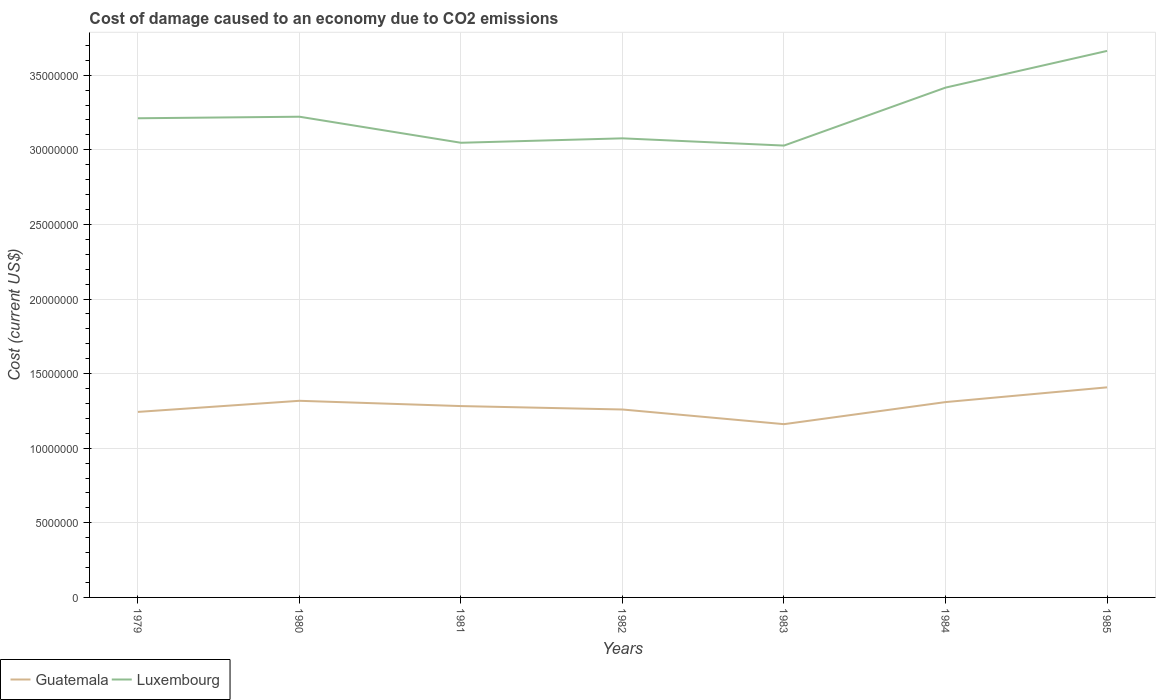Across all years, what is the maximum cost of damage caused due to CO2 emissisons in Luxembourg?
Make the answer very short. 3.03e+07. In which year was the cost of damage caused due to CO2 emissisons in Luxembourg maximum?
Keep it short and to the point. 1983. What is the total cost of damage caused due to CO2 emissisons in Luxembourg in the graph?
Your answer should be compact. -3.88e+06. What is the difference between the highest and the second highest cost of damage caused due to CO2 emissisons in Guatemala?
Make the answer very short. 2.47e+06. What is the difference between the highest and the lowest cost of damage caused due to CO2 emissisons in Luxembourg?
Your response must be concise. 2. How many lines are there?
Offer a very short reply. 2. What is the difference between two consecutive major ticks on the Y-axis?
Keep it short and to the point. 5.00e+06. Are the values on the major ticks of Y-axis written in scientific E-notation?
Your response must be concise. No. Does the graph contain grids?
Give a very brief answer. Yes. How many legend labels are there?
Your answer should be very brief. 2. What is the title of the graph?
Make the answer very short. Cost of damage caused to an economy due to CO2 emissions. Does "Burundi" appear as one of the legend labels in the graph?
Make the answer very short. No. What is the label or title of the X-axis?
Your answer should be compact. Years. What is the label or title of the Y-axis?
Your response must be concise. Cost (current US$). What is the Cost (current US$) of Guatemala in 1979?
Keep it short and to the point. 1.24e+07. What is the Cost (current US$) in Luxembourg in 1979?
Make the answer very short. 3.21e+07. What is the Cost (current US$) of Guatemala in 1980?
Your response must be concise. 1.32e+07. What is the Cost (current US$) in Luxembourg in 1980?
Provide a short and direct response. 3.22e+07. What is the Cost (current US$) in Guatemala in 1981?
Offer a terse response. 1.28e+07. What is the Cost (current US$) in Luxembourg in 1981?
Give a very brief answer. 3.05e+07. What is the Cost (current US$) in Guatemala in 1982?
Give a very brief answer. 1.26e+07. What is the Cost (current US$) in Luxembourg in 1982?
Offer a terse response. 3.08e+07. What is the Cost (current US$) of Guatemala in 1983?
Make the answer very short. 1.16e+07. What is the Cost (current US$) in Luxembourg in 1983?
Your answer should be compact. 3.03e+07. What is the Cost (current US$) in Guatemala in 1984?
Ensure brevity in your answer.  1.31e+07. What is the Cost (current US$) in Luxembourg in 1984?
Make the answer very short. 3.42e+07. What is the Cost (current US$) in Guatemala in 1985?
Your answer should be very brief. 1.41e+07. What is the Cost (current US$) in Luxembourg in 1985?
Your response must be concise. 3.66e+07. Across all years, what is the maximum Cost (current US$) in Guatemala?
Provide a succinct answer. 1.41e+07. Across all years, what is the maximum Cost (current US$) of Luxembourg?
Offer a very short reply. 3.66e+07. Across all years, what is the minimum Cost (current US$) in Guatemala?
Your response must be concise. 1.16e+07. Across all years, what is the minimum Cost (current US$) in Luxembourg?
Give a very brief answer. 3.03e+07. What is the total Cost (current US$) in Guatemala in the graph?
Your answer should be compact. 8.98e+07. What is the total Cost (current US$) of Luxembourg in the graph?
Offer a very short reply. 2.27e+08. What is the difference between the Cost (current US$) of Guatemala in 1979 and that in 1980?
Keep it short and to the point. -7.45e+05. What is the difference between the Cost (current US$) in Luxembourg in 1979 and that in 1980?
Provide a short and direct response. -1.04e+05. What is the difference between the Cost (current US$) in Guatemala in 1979 and that in 1981?
Ensure brevity in your answer.  -3.90e+05. What is the difference between the Cost (current US$) in Luxembourg in 1979 and that in 1981?
Your answer should be very brief. 1.64e+06. What is the difference between the Cost (current US$) in Guatemala in 1979 and that in 1982?
Keep it short and to the point. -1.62e+05. What is the difference between the Cost (current US$) in Luxembourg in 1979 and that in 1982?
Make the answer very short. 1.35e+06. What is the difference between the Cost (current US$) of Guatemala in 1979 and that in 1983?
Provide a short and direct response. 8.21e+05. What is the difference between the Cost (current US$) in Luxembourg in 1979 and that in 1983?
Your answer should be very brief. 1.83e+06. What is the difference between the Cost (current US$) of Guatemala in 1979 and that in 1984?
Provide a short and direct response. -6.58e+05. What is the difference between the Cost (current US$) of Luxembourg in 1979 and that in 1984?
Give a very brief answer. -2.05e+06. What is the difference between the Cost (current US$) in Guatemala in 1979 and that in 1985?
Ensure brevity in your answer.  -1.65e+06. What is the difference between the Cost (current US$) in Luxembourg in 1979 and that in 1985?
Ensure brevity in your answer.  -4.51e+06. What is the difference between the Cost (current US$) of Guatemala in 1980 and that in 1981?
Make the answer very short. 3.55e+05. What is the difference between the Cost (current US$) in Luxembourg in 1980 and that in 1981?
Offer a terse response. 1.75e+06. What is the difference between the Cost (current US$) of Guatemala in 1980 and that in 1982?
Give a very brief answer. 5.83e+05. What is the difference between the Cost (current US$) of Luxembourg in 1980 and that in 1982?
Your response must be concise. 1.45e+06. What is the difference between the Cost (current US$) in Guatemala in 1980 and that in 1983?
Keep it short and to the point. 1.57e+06. What is the difference between the Cost (current US$) in Luxembourg in 1980 and that in 1983?
Your answer should be very brief. 1.93e+06. What is the difference between the Cost (current US$) of Guatemala in 1980 and that in 1984?
Your answer should be very brief. 8.67e+04. What is the difference between the Cost (current US$) of Luxembourg in 1980 and that in 1984?
Give a very brief answer. -1.95e+06. What is the difference between the Cost (current US$) in Guatemala in 1980 and that in 1985?
Keep it short and to the point. -9.01e+05. What is the difference between the Cost (current US$) of Luxembourg in 1980 and that in 1985?
Your answer should be compact. -4.41e+06. What is the difference between the Cost (current US$) of Guatemala in 1981 and that in 1982?
Make the answer very short. 2.29e+05. What is the difference between the Cost (current US$) of Luxembourg in 1981 and that in 1982?
Your answer should be very brief. -2.97e+05. What is the difference between the Cost (current US$) of Guatemala in 1981 and that in 1983?
Ensure brevity in your answer.  1.21e+06. What is the difference between the Cost (current US$) in Luxembourg in 1981 and that in 1983?
Give a very brief answer. 1.89e+05. What is the difference between the Cost (current US$) in Guatemala in 1981 and that in 1984?
Provide a succinct answer. -2.68e+05. What is the difference between the Cost (current US$) of Luxembourg in 1981 and that in 1984?
Your response must be concise. -3.70e+06. What is the difference between the Cost (current US$) of Guatemala in 1981 and that in 1985?
Your answer should be compact. -1.26e+06. What is the difference between the Cost (current US$) in Luxembourg in 1981 and that in 1985?
Offer a terse response. -6.16e+06. What is the difference between the Cost (current US$) in Guatemala in 1982 and that in 1983?
Your response must be concise. 9.83e+05. What is the difference between the Cost (current US$) of Luxembourg in 1982 and that in 1983?
Your response must be concise. 4.85e+05. What is the difference between the Cost (current US$) in Guatemala in 1982 and that in 1984?
Your response must be concise. -4.97e+05. What is the difference between the Cost (current US$) in Luxembourg in 1982 and that in 1984?
Your response must be concise. -3.40e+06. What is the difference between the Cost (current US$) in Guatemala in 1982 and that in 1985?
Your answer should be compact. -1.48e+06. What is the difference between the Cost (current US$) of Luxembourg in 1982 and that in 1985?
Give a very brief answer. -5.86e+06. What is the difference between the Cost (current US$) of Guatemala in 1983 and that in 1984?
Your answer should be very brief. -1.48e+06. What is the difference between the Cost (current US$) of Luxembourg in 1983 and that in 1984?
Your answer should be very brief. -3.88e+06. What is the difference between the Cost (current US$) in Guatemala in 1983 and that in 1985?
Your answer should be very brief. -2.47e+06. What is the difference between the Cost (current US$) of Luxembourg in 1983 and that in 1985?
Your answer should be very brief. -6.34e+06. What is the difference between the Cost (current US$) of Guatemala in 1984 and that in 1985?
Provide a short and direct response. -9.88e+05. What is the difference between the Cost (current US$) in Luxembourg in 1984 and that in 1985?
Your answer should be compact. -2.46e+06. What is the difference between the Cost (current US$) of Guatemala in 1979 and the Cost (current US$) of Luxembourg in 1980?
Offer a terse response. -1.98e+07. What is the difference between the Cost (current US$) in Guatemala in 1979 and the Cost (current US$) in Luxembourg in 1981?
Ensure brevity in your answer.  -1.80e+07. What is the difference between the Cost (current US$) of Guatemala in 1979 and the Cost (current US$) of Luxembourg in 1982?
Your answer should be compact. -1.83e+07. What is the difference between the Cost (current US$) of Guatemala in 1979 and the Cost (current US$) of Luxembourg in 1983?
Keep it short and to the point. -1.79e+07. What is the difference between the Cost (current US$) in Guatemala in 1979 and the Cost (current US$) in Luxembourg in 1984?
Keep it short and to the point. -2.17e+07. What is the difference between the Cost (current US$) of Guatemala in 1979 and the Cost (current US$) of Luxembourg in 1985?
Your answer should be very brief. -2.42e+07. What is the difference between the Cost (current US$) of Guatemala in 1980 and the Cost (current US$) of Luxembourg in 1981?
Offer a terse response. -1.73e+07. What is the difference between the Cost (current US$) in Guatemala in 1980 and the Cost (current US$) in Luxembourg in 1982?
Your answer should be compact. -1.76e+07. What is the difference between the Cost (current US$) of Guatemala in 1980 and the Cost (current US$) of Luxembourg in 1983?
Make the answer very short. -1.71e+07. What is the difference between the Cost (current US$) in Guatemala in 1980 and the Cost (current US$) in Luxembourg in 1984?
Provide a short and direct response. -2.10e+07. What is the difference between the Cost (current US$) of Guatemala in 1980 and the Cost (current US$) of Luxembourg in 1985?
Ensure brevity in your answer.  -2.35e+07. What is the difference between the Cost (current US$) in Guatemala in 1981 and the Cost (current US$) in Luxembourg in 1982?
Make the answer very short. -1.79e+07. What is the difference between the Cost (current US$) in Guatemala in 1981 and the Cost (current US$) in Luxembourg in 1983?
Ensure brevity in your answer.  -1.75e+07. What is the difference between the Cost (current US$) in Guatemala in 1981 and the Cost (current US$) in Luxembourg in 1984?
Your answer should be very brief. -2.13e+07. What is the difference between the Cost (current US$) in Guatemala in 1981 and the Cost (current US$) in Luxembourg in 1985?
Provide a succinct answer. -2.38e+07. What is the difference between the Cost (current US$) in Guatemala in 1982 and the Cost (current US$) in Luxembourg in 1983?
Ensure brevity in your answer.  -1.77e+07. What is the difference between the Cost (current US$) of Guatemala in 1982 and the Cost (current US$) of Luxembourg in 1984?
Make the answer very short. -2.16e+07. What is the difference between the Cost (current US$) of Guatemala in 1982 and the Cost (current US$) of Luxembourg in 1985?
Offer a very short reply. -2.40e+07. What is the difference between the Cost (current US$) in Guatemala in 1983 and the Cost (current US$) in Luxembourg in 1984?
Make the answer very short. -2.26e+07. What is the difference between the Cost (current US$) in Guatemala in 1983 and the Cost (current US$) in Luxembourg in 1985?
Your response must be concise. -2.50e+07. What is the difference between the Cost (current US$) in Guatemala in 1984 and the Cost (current US$) in Luxembourg in 1985?
Provide a short and direct response. -2.35e+07. What is the average Cost (current US$) of Guatemala per year?
Provide a short and direct response. 1.28e+07. What is the average Cost (current US$) of Luxembourg per year?
Your response must be concise. 3.24e+07. In the year 1979, what is the difference between the Cost (current US$) of Guatemala and Cost (current US$) of Luxembourg?
Give a very brief answer. -1.97e+07. In the year 1980, what is the difference between the Cost (current US$) in Guatemala and Cost (current US$) in Luxembourg?
Your answer should be compact. -1.90e+07. In the year 1981, what is the difference between the Cost (current US$) of Guatemala and Cost (current US$) of Luxembourg?
Offer a terse response. -1.76e+07. In the year 1982, what is the difference between the Cost (current US$) of Guatemala and Cost (current US$) of Luxembourg?
Provide a succinct answer. -1.82e+07. In the year 1983, what is the difference between the Cost (current US$) of Guatemala and Cost (current US$) of Luxembourg?
Give a very brief answer. -1.87e+07. In the year 1984, what is the difference between the Cost (current US$) of Guatemala and Cost (current US$) of Luxembourg?
Your response must be concise. -2.11e+07. In the year 1985, what is the difference between the Cost (current US$) in Guatemala and Cost (current US$) in Luxembourg?
Your answer should be very brief. -2.25e+07. What is the ratio of the Cost (current US$) in Guatemala in 1979 to that in 1980?
Provide a succinct answer. 0.94. What is the ratio of the Cost (current US$) of Guatemala in 1979 to that in 1981?
Ensure brevity in your answer.  0.97. What is the ratio of the Cost (current US$) of Luxembourg in 1979 to that in 1981?
Ensure brevity in your answer.  1.05. What is the ratio of the Cost (current US$) of Guatemala in 1979 to that in 1982?
Offer a terse response. 0.99. What is the ratio of the Cost (current US$) of Luxembourg in 1979 to that in 1982?
Offer a terse response. 1.04. What is the ratio of the Cost (current US$) in Guatemala in 1979 to that in 1983?
Provide a short and direct response. 1.07. What is the ratio of the Cost (current US$) in Luxembourg in 1979 to that in 1983?
Your response must be concise. 1.06. What is the ratio of the Cost (current US$) of Guatemala in 1979 to that in 1984?
Offer a terse response. 0.95. What is the ratio of the Cost (current US$) in Luxembourg in 1979 to that in 1984?
Ensure brevity in your answer.  0.94. What is the ratio of the Cost (current US$) in Guatemala in 1979 to that in 1985?
Your answer should be very brief. 0.88. What is the ratio of the Cost (current US$) of Luxembourg in 1979 to that in 1985?
Provide a short and direct response. 0.88. What is the ratio of the Cost (current US$) of Guatemala in 1980 to that in 1981?
Provide a succinct answer. 1.03. What is the ratio of the Cost (current US$) in Luxembourg in 1980 to that in 1981?
Your answer should be compact. 1.06. What is the ratio of the Cost (current US$) in Guatemala in 1980 to that in 1982?
Make the answer very short. 1.05. What is the ratio of the Cost (current US$) of Luxembourg in 1980 to that in 1982?
Your answer should be compact. 1.05. What is the ratio of the Cost (current US$) of Guatemala in 1980 to that in 1983?
Your answer should be compact. 1.13. What is the ratio of the Cost (current US$) of Luxembourg in 1980 to that in 1983?
Keep it short and to the point. 1.06. What is the ratio of the Cost (current US$) in Guatemala in 1980 to that in 1984?
Ensure brevity in your answer.  1.01. What is the ratio of the Cost (current US$) of Luxembourg in 1980 to that in 1984?
Your response must be concise. 0.94. What is the ratio of the Cost (current US$) of Guatemala in 1980 to that in 1985?
Your answer should be very brief. 0.94. What is the ratio of the Cost (current US$) of Luxembourg in 1980 to that in 1985?
Your response must be concise. 0.88. What is the ratio of the Cost (current US$) in Guatemala in 1981 to that in 1982?
Ensure brevity in your answer.  1.02. What is the ratio of the Cost (current US$) in Luxembourg in 1981 to that in 1982?
Your answer should be very brief. 0.99. What is the ratio of the Cost (current US$) of Guatemala in 1981 to that in 1983?
Give a very brief answer. 1.1. What is the ratio of the Cost (current US$) of Guatemala in 1981 to that in 1984?
Keep it short and to the point. 0.98. What is the ratio of the Cost (current US$) of Luxembourg in 1981 to that in 1984?
Provide a succinct answer. 0.89. What is the ratio of the Cost (current US$) in Guatemala in 1981 to that in 1985?
Keep it short and to the point. 0.91. What is the ratio of the Cost (current US$) of Luxembourg in 1981 to that in 1985?
Your answer should be compact. 0.83. What is the ratio of the Cost (current US$) in Guatemala in 1982 to that in 1983?
Offer a very short reply. 1.08. What is the ratio of the Cost (current US$) in Guatemala in 1982 to that in 1984?
Make the answer very short. 0.96. What is the ratio of the Cost (current US$) of Luxembourg in 1982 to that in 1984?
Ensure brevity in your answer.  0.9. What is the ratio of the Cost (current US$) in Guatemala in 1982 to that in 1985?
Offer a terse response. 0.89. What is the ratio of the Cost (current US$) of Luxembourg in 1982 to that in 1985?
Make the answer very short. 0.84. What is the ratio of the Cost (current US$) of Guatemala in 1983 to that in 1984?
Your response must be concise. 0.89. What is the ratio of the Cost (current US$) of Luxembourg in 1983 to that in 1984?
Keep it short and to the point. 0.89. What is the ratio of the Cost (current US$) of Guatemala in 1983 to that in 1985?
Give a very brief answer. 0.82. What is the ratio of the Cost (current US$) of Luxembourg in 1983 to that in 1985?
Provide a succinct answer. 0.83. What is the ratio of the Cost (current US$) in Guatemala in 1984 to that in 1985?
Provide a succinct answer. 0.93. What is the ratio of the Cost (current US$) of Luxembourg in 1984 to that in 1985?
Provide a short and direct response. 0.93. What is the difference between the highest and the second highest Cost (current US$) of Guatemala?
Your answer should be compact. 9.01e+05. What is the difference between the highest and the second highest Cost (current US$) of Luxembourg?
Ensure brevity in your answer.  2.46e+06. What is the difference between the highest and the lowest Cost (current US$) in Guatemala?
Make the answer very short. 2.47e+06. What is the difference between the highest and the lowest Cost (current US$) of Luxembourg?
Offer a terse response. 6.34e+06. 